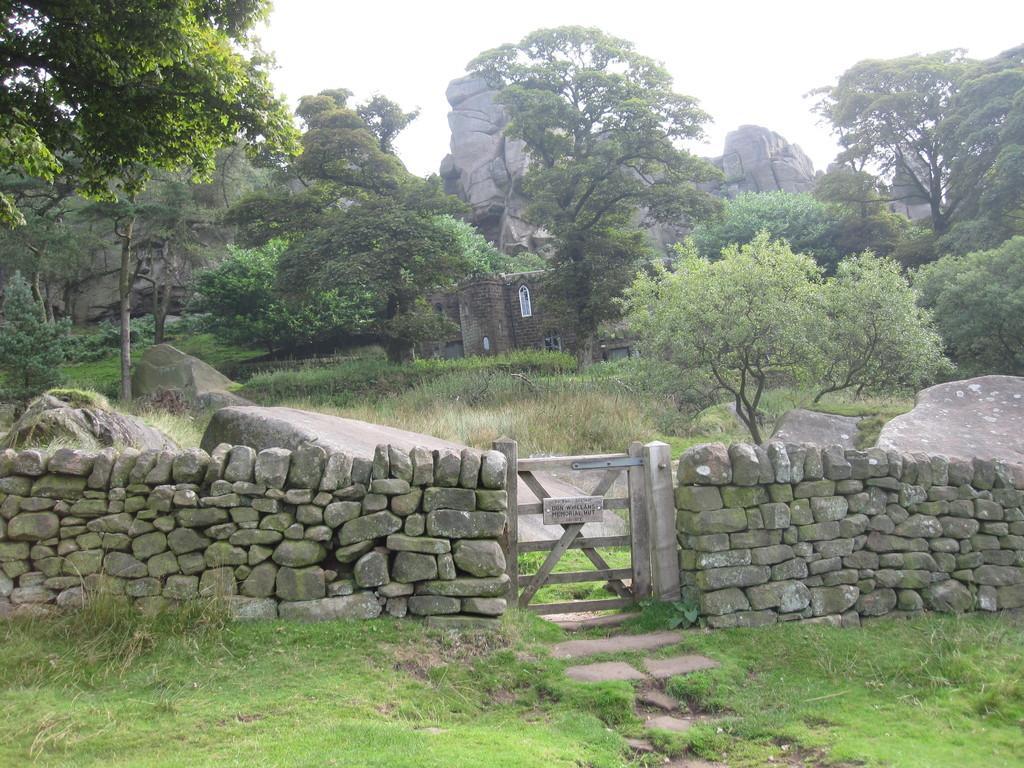Can you describe this image briefly? In the picture we can see a grass surface on it we can see a rock wall with a wooden gate with some board to it and behind it we can see grass, plants, rocks, and some old construction behind it we can see rock hills and in the background we can see a sky. 